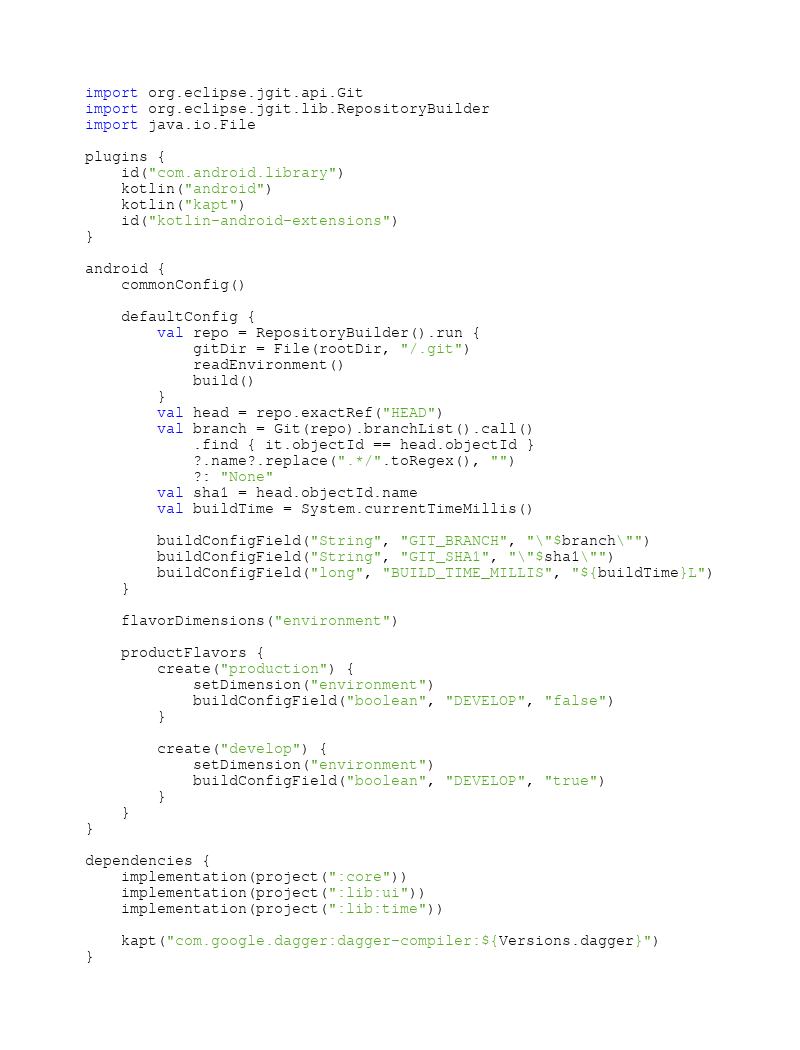<code> <loc_0><loc_0><loc_500><loc_500><_Kotlin_>import org.eclipse.jgit.api.Git
import org.eclipse.jgit.lib.RepositoryBuilder
import java.io.File

plugins {
    id("com.android.library")
    kotlin("android")
    kotlin("kapt")
    id("kotlin-android-extensions")
}

android {
    commonConfig()

    defaultConfig {
        val repo = RepositoryBuilder().run {
            gitDir = File(rootDir, "/.git")
            readEnvironment()
            build()
        }
        val head = repo.exactRef("HEAD")
        val branch = Git(repo).branchList().call()
            .find { it.objectId == head.objectId }
            ?.name?.replace(".*/".toRegex(), "")
            ?: "None"
        val sha1 = head.objectId.name
        val buildTime = System.currentTimeMillis()

        buildConfigField("String", "GIT_BRANCH", "\"$branch\"")
        buildConfigField("String", "GIT_SHA1", "\"$sha1\"")
        buildConfigField("long", "BUILD_TIME_MILLIS", "${buildTime}L")
    }

    flavorDimensions("environment")

    productFlavors {
        create("production") {
            setDimension("environment")
            buildConfigField("boolean", "DEVELOP", "false")
        }

        create("develop") {
            setDimension("environment")
            buildConfigField("boolean", "DEVELOP", "true")
        }
    }
}

dependencies {
    implementation(project(":core"))
    implementation(project(":lib:ui"))
    implementation(project(":lib:time"))

    kapt("com.google.dagger:dagger-compiler:${Versions.dagger}")
}
</code> 